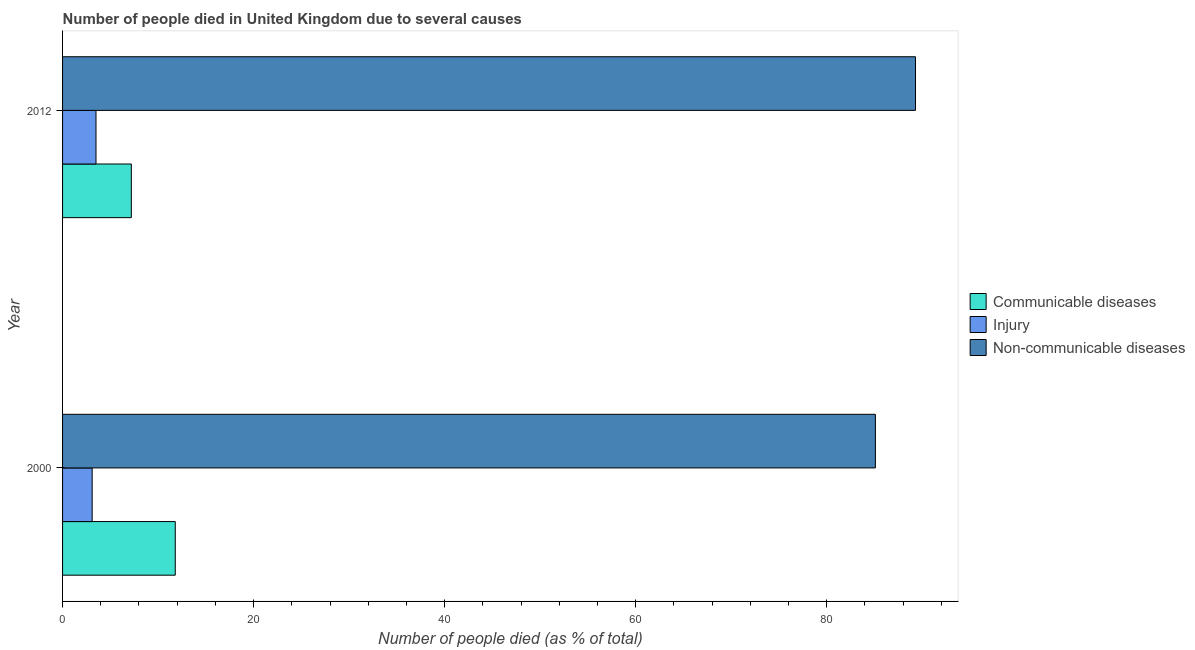How many different coloured bars are there?
Keep it short and to the point. 3. How many groups of bars are there?
Your answer should be compact. 2. Are the number of bars on each tick of the Y-axis equal?
Offer a very short reply. Yes. How many bars are there on the 2nd tick from the bottom?
Your answer should be very brief. 3. What is the label of the 2nd group of bars from the top?
Make the answer very short. 2000. In how many cases, is the number of bars for a given year not equal to the number of legend labels?
Your response must be concise. 0. What is the number of people who died of communicable diseases in 2000?
Offer a very short reply. 11.8. Across all years, what is the minimum number of people who dies of non-communicable diseases?
Make the answer very short. 85.1. What is the difference between the number of people who dies of non-communicable diseases in 2000 and the number of people who died of communicable diseases in 2012?
Your answer should be very brief. 77.9. In the year 2012, what is the difference between the number of people who died of injury and number of people who dies of non-communicable diseases?
Keep it short and to the point. -85.8. In how many years, is the number of people who dies of non-communicable diseases greater than 48 %?
Provide a succinct answer. 2. What is the ratio of the number of people who died of communicable diseases in 2000 to that in 2012?
Provide a short and direct response. 1.64. Is the number of people who dies of non-communicable diseases in 2000 less than that in 2012?
Provide a short and direct response. Yes. Is the difference between the number of people who dies of non-communicable diseases in 2000 and 2012 greater than the difference between the number of people who died of injury in 2000 and 2012?
Ensure brevity in your answer.  No. In how many years, is the number of people who died of communicable diseases greater than the average number of people who died of communicable diseases taken over all years?
Your answer should be compact. 1. What does the 1st bar from the top in 2012 represents?
Provide a succinct answer. Non-communicable diseases. What does the 3rd bar from the bottom in 2012 represents?
Offer a terse response. Non-communicable diseases. Is it the case that in every year, the sum of the number of people who died of communicable diseases and number of people who died of injury is greater than the number of people who dies of non-communicable diseases?
Offer a very short reply. No. How many years are there in the graph?
Give a very brief answer. 2. Where does the legend appear in the graph?
Your answer should be compact. Center right. How many legend labels are there?
Provide a succinct answer. 3. How are the legend labels stacked?
Your response must be concise. Vertical. What is the title of the graph?
Offer a terse response. Number of people died in United Kingdom due to several causes. Does "Solid fuel" appear as one of the legend labels in the graph?
Make the answer very short. No. What is the label or title of the X-axis?
Offer a terse response. Number of people died (as % of total). What is the Number of people died (as % of total) of Communicable diseases in 2000?
Your response must be concise. 11.8. What is the Number of people died (as % of total) of Non-communicable diseases in 2000?
Offer a terse response. 85.1. What is the Number of people died (as % of total) of Non-communicable diseases in 2012?
Provide a short and direct response. 89.3. Across all years, what is the maximum Number of people died (as % of total) of Communicable diseases?
Give a very brief answer. 11.8. Across all years, what is the maximum Number of people died (as % of total) of Injury?
Offer a very short reply. 3.5. Across all years, what is the maximum Number of people died (as % of total) in Non-communicable diseases?
Offer a very short reply. 89.3. Across all years, what is the minimum Number of people died (as % of total) of Communicable diseases?
Offer a terse response. 7.2. Across all years, what is the minimum Number of people died (as % of total) in Non-communicable diseases?
Give a very brief answer. 85.1. What is the total Number of people died (as % of total) of Non-communicable diseases in the graph?
Give a very brief answer. 174.4. What is the difference between the Number of people died (as % of total) in Communicable diseases in 2000 and the Number of people died (as % of total) in Injury in 2012?
Ensure brevity in your answer.  8.3. What is the difference between the Number of people died (as % of total) in Communicable diseases in 2000 and the Number of people died (as % of total) in Non-communicable diseases in 2012?
Your answer should be very brief. -77.5. What is the difference between the Number of people died (as % of total) of Injury in 2000 and the Number of people died (as % of total) of Non-communicable diseases in 2012?
Your response must be concise. -86.2. What is the average Number of people died (as % of total) of Injury per year?
Offer a very short reply. 3.3. What is the average Number of people died (as % of total) of Non-communicable diseases per year?
Give a very brief answer. 87.2. In the year 2000, what is the difference between the Number of people died (as % of total) in Communicable diseases and Number of people died (as % of total) in Injury?
Provide a short and direct response. 8.7. In the year 2000, what is the difference between the Number of people died (as % of total) in Communicable diseases and Number of people died (as % of total) in Non-communicable diseases?
Ensure brevity in your answer.  -73.3. In the year 2000, what is the difference between the Number of people died (as % of total) of Injury and Number of people died (as % of total) of Non-communicable diseases?
Keep it short and to the point. -82. In the year 2012, what is the difference between the Number of people died (as % of total) of Communicable diseases and Number of people died (as % of total) of Injury?
Provide a short and direct response. 3.7. In the year 2012, what is the difference between the Number of people died (as % of total) in Communicable diseases and Number of people died (as % of total) in Non-communicable diseases?
Provide a short and direct response. -82.1. In the year 2012, what is the difference between the Number of people died (as % of total) of Injury and Number of people died (as % of total) of Non-communicable diseases?
Provide a short and direct response. -85.8. What is the ratio of the Number of people died (as % of total) in Communicable diseases in 2000 to that in 2012?
Provide a succinct answer. 1.64. What is the ratio of the Number of people died (as % of total) in Injury in 2000 to that in 2012?
Provide a succinct answer. 0.89. What is the ratio of the Number of people died (as % of total) in Non-communicable diseases in 2000 to that in 2012?
Give a very brief answer. 0.95. What is the difference between the highest and the lowest Number of people died (as % of total) of Injury?
Give a very brief answer. 0.4. What is the difference between the highest and the lowest Number of people died (as % of total) in Non-communicable diseases?
Offer a terse response. 4.2. 